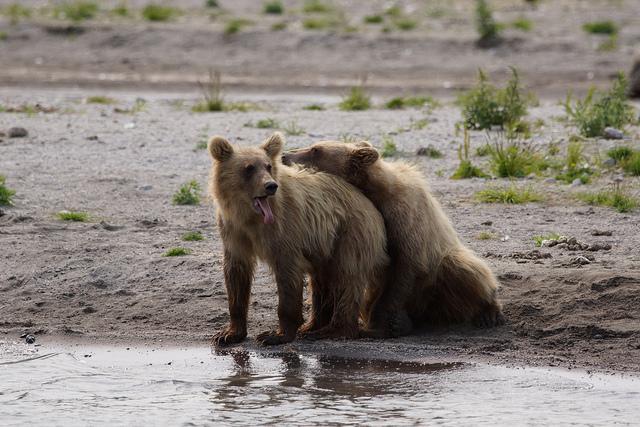What are these animals doing?
Short answer required. Playing. Would these animals make good housepets?
Answer briefly. No. Is this the only bear here?
Short answer required. No. Are the animals near water?
Quick response, please. Yes. 